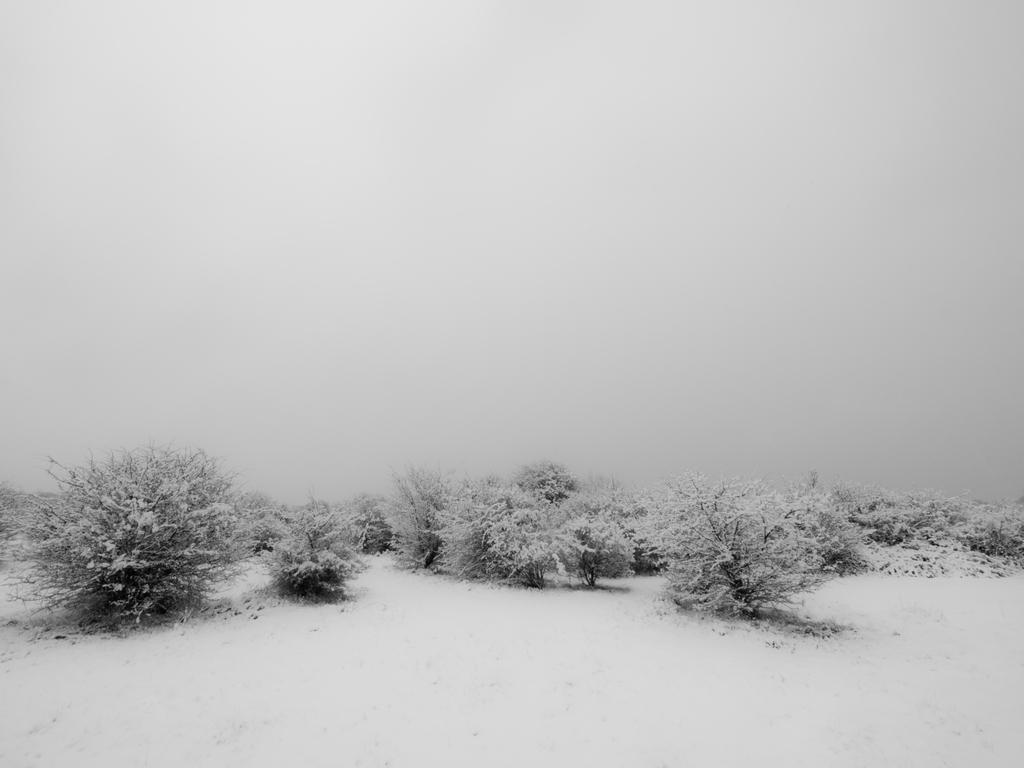What type of plants can be seen in the image? There are small plants in the image. Where are the plants located? The plants are in the snow. What is the condition of the trees in the image? The trees in the image are covered with snow. What book is the woman reading in the image? There is no woman or book present in the image; it features small plants and trees covered with snow. 